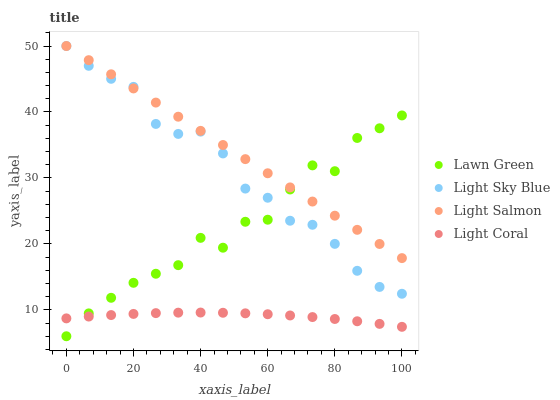Does Light Coral have the minimum area under the curve?
Answer yes or no. Yes. Does Light Salmon have the maximum area under the curve?
Answer yes or no. Yes. Does Lawn Green have the minimum area under the curve?
Answer yes or no. No. Does Lawn Green have the maximum area under the curve?
Answer yes or no. No. Is Light Salmon the smoothest?
Answer yes or no. Yes. Is Lawn Green the roughest?
Answer yes or no. Yes. Is Lawn Green the smoothest?
Answer yes or no. No. Is Light Salmon the roughest?
Answer yes or no. No. Does Lawn Green have the lowest value?
Answer yes or no. Yes. Does Light Salmon have the lowest value?
Answer yes or no. No. Does Light Sky Blue have the highest value?
Answer yes or no. Yes. Does Lawn Green have the highest value?
Answer yes or no. No. Is Light Coral less than Light Salmon?
Answer yes or no. Yes. Is Light Sky Blue greater than Light Coral?
Answer yes or no. Yes. Does Light Salmon intersect Lawn Green?
Answer yes or no. Yes. Is Light Salmon less than Lawn Green?
Answer yes or no. No. Is Light Salmon greater than Lawn Green?
Answer yes or no. No. Does Light Coral intersect Light Salmon?
Answer yes or no. No. 